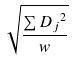Convert formula to latex. <formula><loc_0><loc_0><loc_500><loc_500>\sqrt { \frac { \sum { D _ { j } } ^ { 2 } } { w } }</formula> 